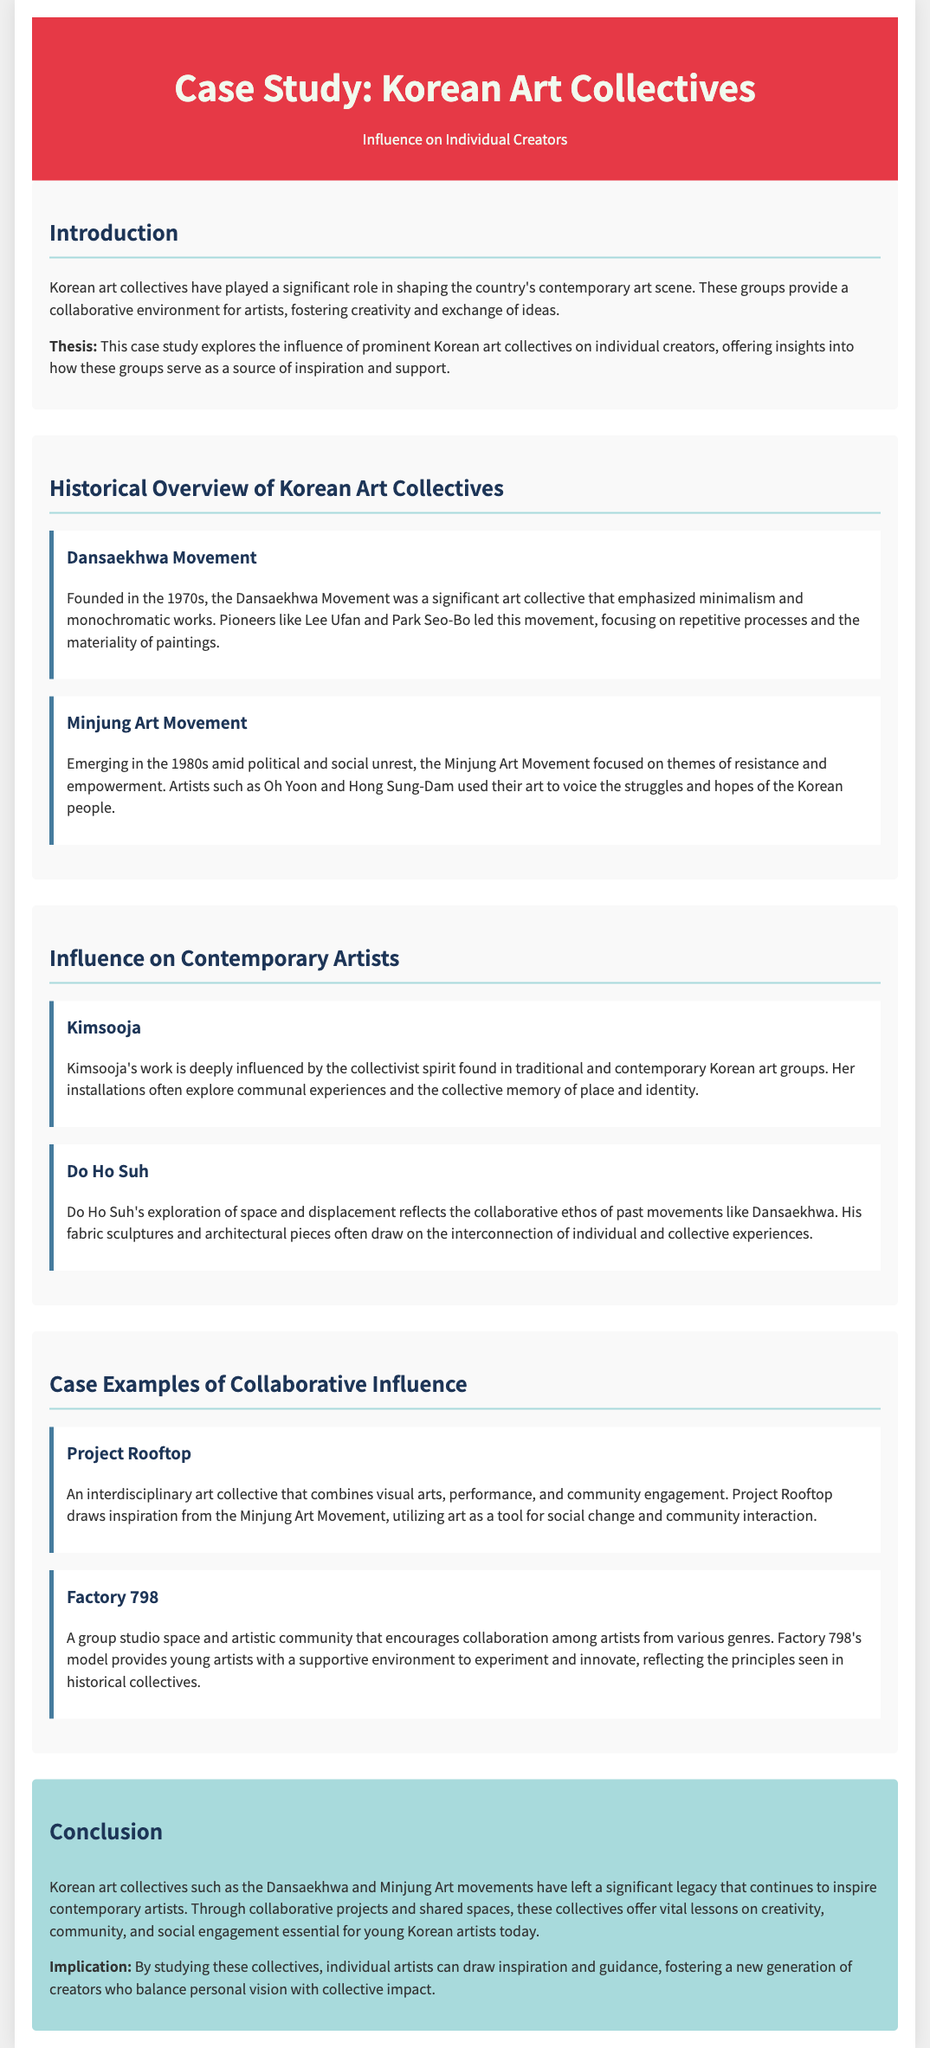What is the title of the case study? The title of the case study is presented in the header of the document.
Answer: Case Study: Korean Art Collectives Who were the pioneers of the Dansaekhwa Movement? The document mentions the pioneers who led the Dansaekhwa Movement.
Answer: Lee Ufan and Park Seo-Bo In which decade did the Minjung Art Movement emerge? The emergence of the Minjung Art Movement is detailed in the historical overview section.
Answer: 1980s What type of artwork does Kimsooja primarily create? The document describes the focus of Kimsooja's work in relation to Korean art collectives.
Answer: Installations What social themes did the Minjung Art Movement address? The document states the themes that were highlighted by artists in the Minjung Art Movement.
Answer: Resistance and empowerment Which collective draws inspiration from the Minjung Art Movement? The document includes details about a collective that utilizes art as a social change tool.
Answer: Project Rooftop What collaborative practice does Factory 798 provide? Information about Factory 798's model and its purpose is covered in the document.
Answer: Supportive environment What is the implication of studying Korean art collectives for individual artists? The document mentions the implications for artists studying these collectives in the conclusion.
Answer: Inspiration and guidance 